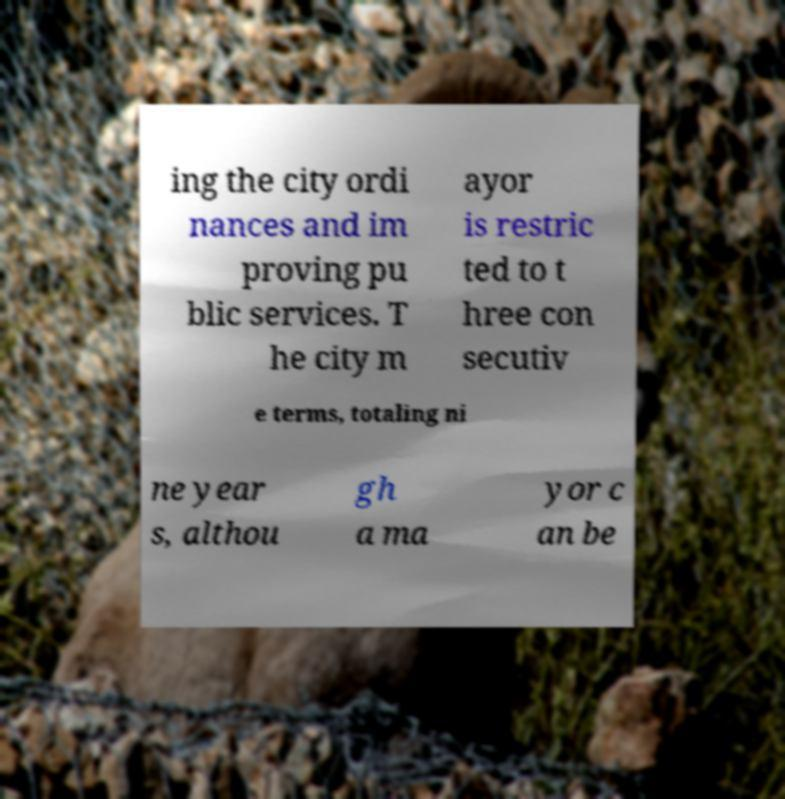Could you extract and type out the text from this image? ing the city ordi nances and im proving pu blic services. T he city m ayor is restric ted to t hree con secutiv e terms, totaling ni ne year s, althou gh a ma yor c an be 